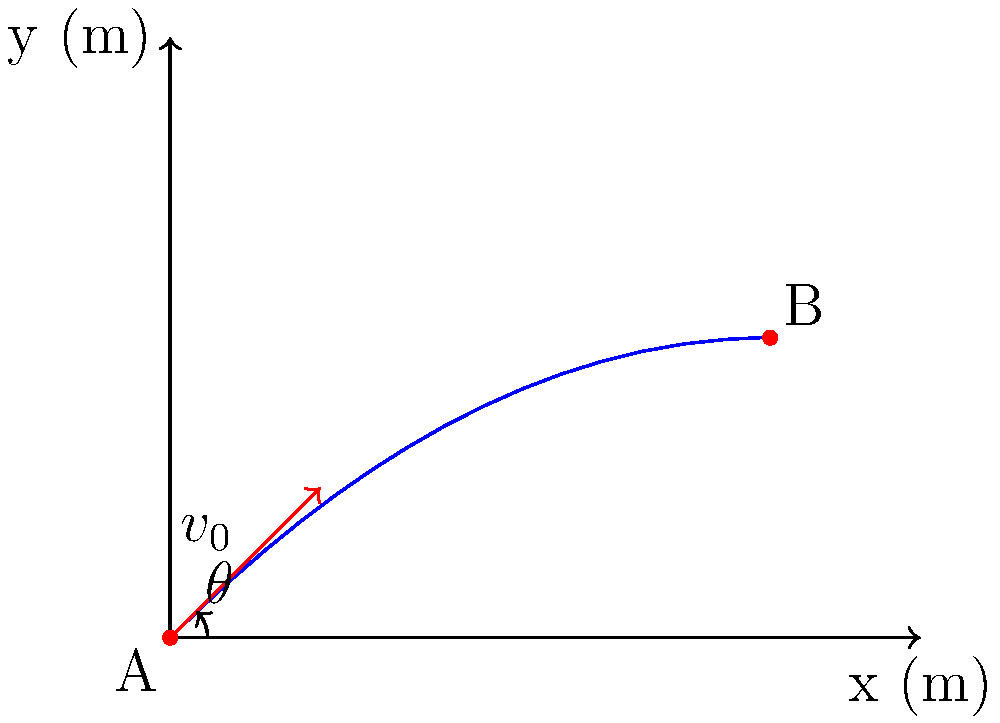As a basketball coach, you're teaching your players about shot trajectories. A player shoots a basketball from point A with an initial velocity of 12 m/s at an angle of 45° above the horizontal. Assuming no air resistance, at what horizontal distance (in meters) from point A will the ball reach its maximum height? Use $g = 9.8 \text{ m/s}^2$ for acceleration due to gravity. Let's approach this step-by-step:

1) First, we need to understand that the horizontal and vertical components of motion can be treated separately.

2) The time to reach maximum height is when the vertical velocity becomes zero. We can use this to find the time:

   $v_y = v_0 \sin(\theta) - gt$
   
   At the highest point: $0 = v_0 \sin(\theta) - gt_{max}$

3) Solve for $t_{max}$:

   $t_{max} = \frac{v_0 \sin(\theta)}{g}$

4) Now, let's plug in our values:
   
   $v_0 = 12 \text{ m/s}$
   $\theta = 45°$
   $g = 9.8 \text{ m/s}^2$

   $t_{max} = \frac{12 \sin(45°)}{9.8} = \frac{12 \cdot 0.707}{9.8} \approx 0.866 \text{ s}$

5) To find the horizontal distance, we use the horizontal component of velocity and the time we just calculated:

   $x = v_0 \cos(\theta) \cdot t_{max}$

6) Plugging in our values:

   $x = 12 \cos(45°) \cdot 0.866$
   $x = 12 \cdot 0.707 \cdot 0.866 \approx 7.35 \text{ m}$

Therefore, the ball will reach its maximum height approximately 7.35 meters from the starting point.
Answer: 7.35 m 